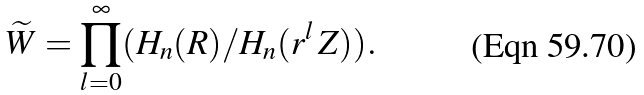Convert formula to latex. <formula><loc_0><loc_0><loc_500><loc_500>\widetilde { W } = \prod _ { l = 0 } ^ { \infty } ( H _ { n } ( { R } ) / H _ { n } ( r ^ { l } \, { Z } ) ) .</formula> 